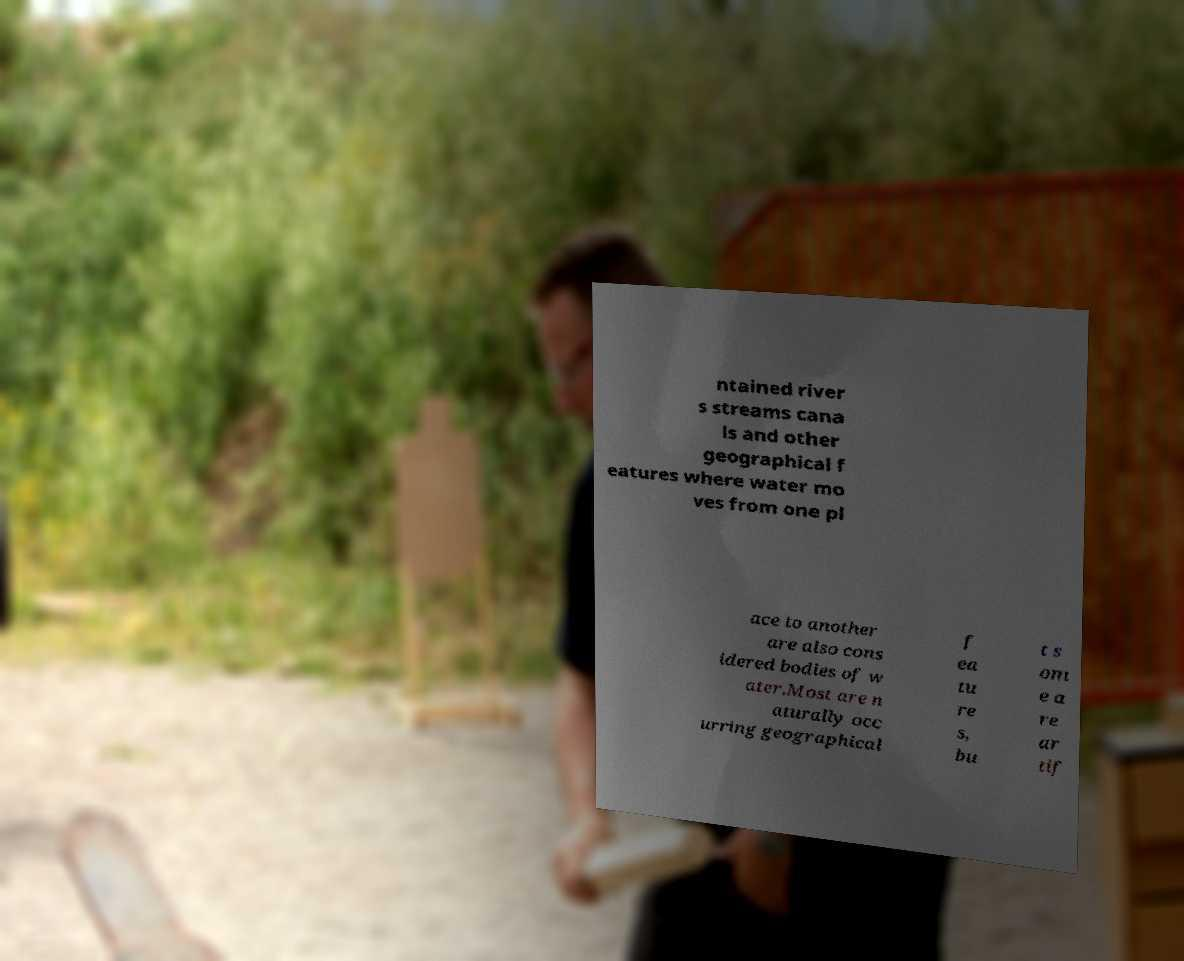Can you read and provide the text displayed in the image?This photo seems to have some interesting text. Can you extract and type it out for me? ntained river s streams cana ls and other geographical f eatures where water mo ves from one pl ace to another are also cons idered bodies of w ater.Most are n aturally occ urring geographical f ea tu re s, bu t s om e a re ar tif 